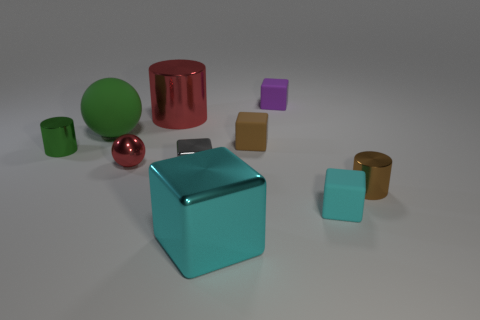Are there any other things of the same color as the metal sphere?
Make the answer very short. Yes. What is the material of the tiny cylinder on the left side of the tiny brown cylinder to the right of the tiny brown block?
Offer a terse response. Metal. Is there a tiny cyan metallic thing of the same shape as the large green thing?
Give a very brief answer. No. What number of other things are the same shape as the large green thing?
Your response must be concise. 1. What is the shape of the tiny metal thing that is behind the tiny gray cube and in front of the green metallic thing?
Your answer should be very brief. Sphere. There is a cyan block that is to the left of the small cyan thing; how big is it?
Your answer should be compact. Large. Do the red shiny sphere and the gray metal cube have the same size?
Your answer should be compact. Yes. Are there fewer purple matte objects on the right side of the brown cylinder than matte cubes on the right side of the purple matte block?
Offer a very short reply. Yes. There is a object that is both left of the big cyan metal thing and behind the large matte sphere; what size is it?
Offer a very short reply. Large. Is there a tiny object in front of the green thing to the right of the tiny cylinder on the left side of the large shiny cube?
Your response must be concise. Yes. 